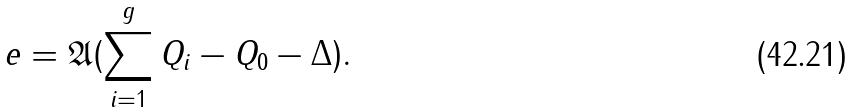Convert formula to latex. <formula><loc_0><loc_0><loc_500><loc_500>e = \mathfrak { A } ( \sum _ { i = 1 } ^ { g } Q _ { i } - Q _ { 0 } - \Delta ) .</formula> 